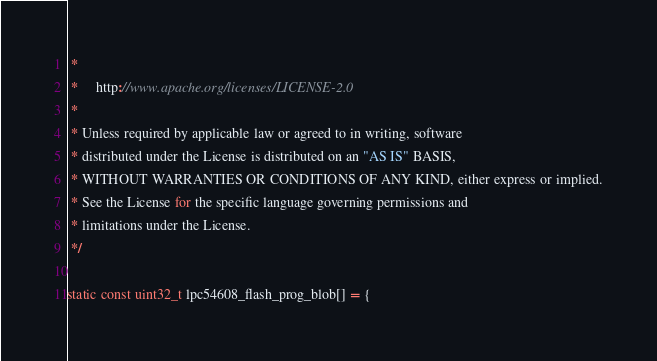Convert code to text. <code><loc_0><loc_0><loc_500><loc_500><_C_> *
 *     http://www.apache.org/licenses/LICENSE-2.0
 *
 * Unless required by applicable law or agreed to in writing, software
 * distributed under the License is distributed on an "AS IS" BASIS,
 * WITHOUT WARRANTIES OR CONDITIONS OF ANY KIND, either express or implied.
 * See the License for the specific language governing permissions and
 * limitations under the License.
 */

static const uint32_t lpc54608_flash_prog_blob[] = {</code> 